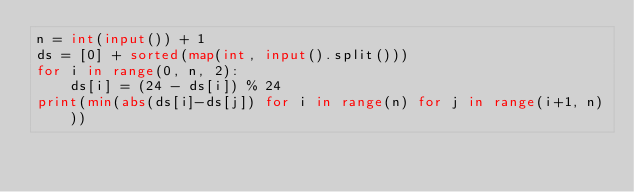<code> <loc_0><loc_0><loc_500><loc_500><_Python_>n = int(input()) + 1
ds = [0] + sorted(map(int, input().split()))
for i in range(0, n, 2):
    ds[i] = (24 - ds[i]) % 24
print(min(abs(ds[i]-ds[j]) for i in range(n) for j in range(i+1, n)))</code> 